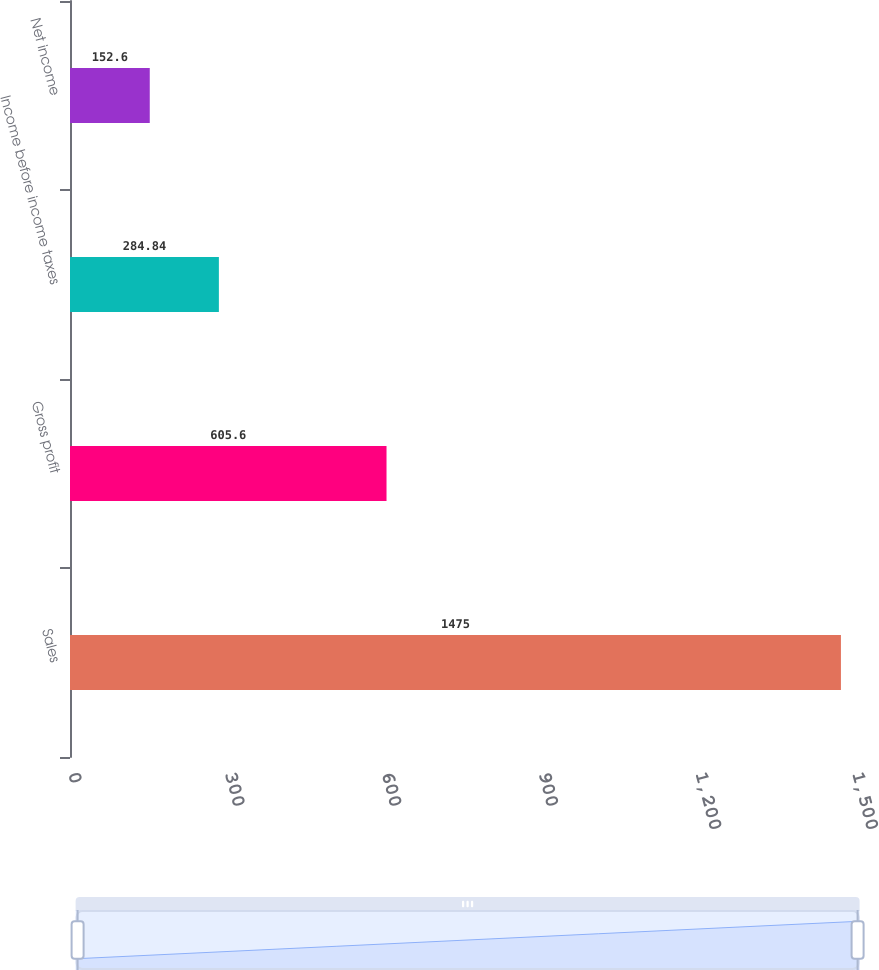<chart> <loc_0><loc_0><loc_500><loc_500><bar_chart><fcel>Sales<fcel>Gross profit<fcel>Income before income taxes<fcel>Net income<nl><fcel>1475<fcel>605.6<fcel>284.84<fcel>152.6<nl></chart> 